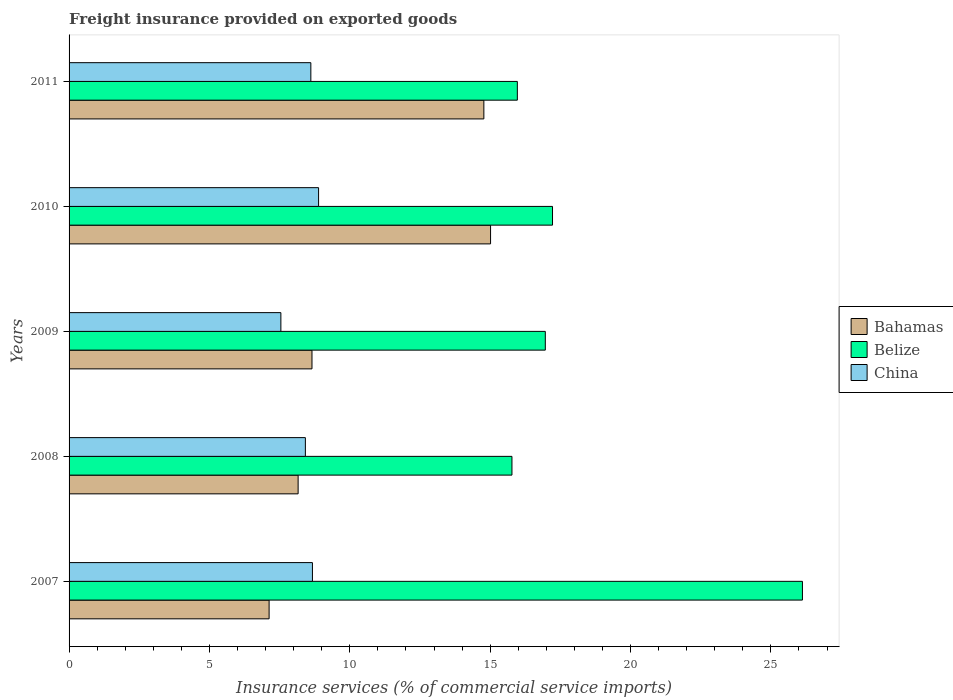How many groups of bars are there?
Provide a succinct answer. 5. Are the number of bars per tick equal to the number of legend labels?
Give a very brief answer. Yes. Are the number of bars on each tick of the Y-axis equal?
Ensure brevity in your answer.  Yes. How many bars are there on the 3rd tick from the top?
Your response must be concise. 3. In how many cases, is the number of bars for a given year not equal to the number of legend labels?
Provide a short and direct response. 0. What is the freight insurance provided on exported goods in Belize in 2011?
Offer a terse response. 15.97. Across all years, what is the maximum freight insurance provided on exported goods in Bahamas?
Provide a short and direct response. 15.01. Across all years, what is the minimum freight insurance provided on exported goods in Bahamas?
Your answer should be compact. 7.13. What is the total freight insurance provided on exported goods in Bahamas in the graph?
Offer a terse response. 53.73. What is the difference between the freight insurance provided on exported goods in Bahamas in 2007 and that in 2010?
Make the answer very short. -7.89. What is the difference between the freight insurance provided on exported goods in Bahamas in 2010 and the freight insurance provided on exported goods in China in 2008?
Provide a short and direct response. 6.6. What is the average freight insurance provided on exported goods in Belize per year?
Make the answer very short. 18.41. In the year 2007, what is the difference between the freight insurance provided on exported goods in Belize and freight insurance provided on exported goods in Bahamas?
Your answer should be compact. 19. What is the ratio of the freight insurance provided on exported goods in China in 2009 to that in 2010?
Your response must be concise. 0.85. What is the difference between the highest and the second highest freight insurance provided on exported goods in Belize?
Your response must be concise. 8.9. What is the difference between the highest and the lowest freight insurance provided on exported goods in China?
Give a very brief answer. 1.34. In how many years, is the freight insurance provided on exported goods in Belize greater than the average freight insurance provided on exported goods in Belize taken over all years?
Provide a short and direct response. 1. Is the sum of the freight insurance provided on exported goods in China in 2007 and 2011 greater than the maximum freight insurance provided on exported goods in Belize across all years?
Keep it short and to the point. No. What does the 1st bar from the top in 2011 represents?
Make the answer very short. China. What does the 3rd bar from the bottom in 2009 represents?
Offer a very short reply. China. Is it the case that in every year, the sum of the freight insurance provided on exported goods in Bahamas and freight insurance provided on exported goods in Belize is greater than the freight insurance provided on exported goods in China?
Keep it short and to the point. Yes. How many bars are there?
Ensure brevity in your answer.  15. How many years are there in the graph?
Keep it short and to the point. 5. Are the values on the major ticks of X-axis written in scientific E-notation?
Provide a succinct answer. No. Where does the legend appear in the graph?
Provide a short and direct response. Center right. How are the legend labels stacked?
Provide a succinct answer. Vertical. What is the title of the graph?
Provide a short and direct response. Freight insurance provided on exported goods. Does "Brazil" appear as one of the legend labels in the graph?
Your answer should be very brief. No. What is the label or title of the X-axis?
Offer a very short reply. Insurance services (% of commercial service imports). What is the Insurance services (% of commercial service imports) in Bahamas in 2007?
Provide a succinct answer. 7.13. What is the Insurance services (% of commercial service imports) of Belize in 2007?
Offer a very short reply. 26.13. What is the Insurance services (% of commercial service imports) of China in 2007?
Your answer should be compact. 8.67. What is the Insurance services (% of commercial service imports) of Bahamas in 2008?
Your response must be concise. 8.16. What is the Insurance services (% of commercial service imports) of Belize in 2008?
Your answer should be very brief. 15.78. What is the Insurance services (% of commercial service imports) in China in 2008?
Provide a short and direct response. 8.42. What is the Insurance services (% of commercial service imports) of Bahamas in 2009?
Make the answer very short. 8.65. What is the Insurance services (% of commercial service imports) of Belize in 2009?
Provide a short and direct response. 16.97. What is the Insurance services (% of commercial service imports) of China in 2009?
Offer a terse response. 7.55. What is the Insurance services (% of commercial service imports) of Bahamas in 2010?
Offer a very short reply. 15.01. What is the Insurance services (% of commercial service imports) of Belize in 2010?
Your answer should be compact. 17.22. What is the Insurance services (% of commercial service imports) in China in 2010?
Provide a short and direct response. 8.89. What is the Insurance services (% of commercial service imports) of Bahamas in 2011?
Ensure brevity in your answer.  14.78. What is the Insurance services (% of commercial service imports) of Belize in 2011?
Offer a very short reply. 15.97. What is the Insurance services (% of commercial service imports) of China in 2011?
Your answer should be very brief. 8.61. Across all years, what is the maximum Insurance services (% of commercial service imports) of Bahamas?
Keep it short and to the point. 15.01. Across all years, what is the maximum Insurance services (% of commercial service imports) of Belize?
Provide a succinct answer. 26.13. Across all years, what is the maximum Insurance services (% of commercial service imports) in China?
Ensure brevity in your answer.  8.89. Across all years, what is the minimum Insurance services (% of commercial service imports) of Bahamas?
Your answer should be very brief. 7.13. Across all years, what is the minimum Insurance services (% of commercial service imports) of Belize?
Give a very brief answer. 15.78. Across all years, what is the minimum Insurance services (% of commercial service imports) in China?
Give a very brief answer. 7.55. What is the total Insurance services (% of commercial service imports) of Bahamas in the graph?
Your answer should be very brief. 53.73. What is the total Insurance services (% of commercial service imports) in Belize in the graph?
Keep it short and to the point. 92.06. What is the total Insurance services (% of commercial service imports) in China in the graph?
Offer a very short reply. 42.13. What is the difference between the Insurance services (% of commercial service imports) in Bahamas in 2007 and that in 2008?
Your answer should be very brief. -1.03. What is the difference between the Insurance services (% of commercial service imports) in Belize in 2007 and that in 2008?
Offer a very short reply. 10.35. What is the difference between the Insurance services (% of commercial service imports) of China in 2007 and that in 2008?
Offer a terse response. 0.25. What is the difference between the Insurance services (% of commercial service imports) of Bahamas in 2007 and that in 2009?
Provide a succinct answer. -1.53. What is the difference between the Insurance services (% of commercial service imports) of Belize in 2007 and that in 2009?
Ensure brevity in your answer.  9.16. What is the difference between the Insurance services (% of commercial service imports) of China in 2007 and that in 2009?
Offer a very short reply. 1.12. What is the difference between the Insurance services (% of commercial service imports) of Bahamas in 2007 and that in 2010?
Give a very brief answer. -7.89. What is the difference between the Insurance services (% of commercial service imports) of Belize in 2007 and that in 2010?
Provide a succinct answer. 8.9. What is the difference between the Insurance services (% of commercial service imports) of China in 2007 and that in 2010?
Offer a very short reply. -0.22. What is the difference between the Insurance services (% of commercial service imports) of Bahamas in 2007 and that in 2011?
Keep it short and to the point. -7.65. What is the difference between the Insurance services (% of commercial service imports) in Belize in 2007 and that in 2011?
Ensure brevity in your answer.  10.16. What is the difference between the Insurance services (% of commercial service imports) of China in 2007 and that in 2011?
Provide a succinct answer. 0.06. What is the difference between the Insurance services (% of commercial service imports) in Bahamas in 2008 and that in 2009?
Make the answer very short. -0.49. What is the difference between the Insurance services (% of commercial service imports) of Belize in 2008 and that in 2009?
Offer a very short reply. -1.19. What is the difference between the Insurance services (% of commercial service imports) of China in 2008 and that in 2009?
Provide a succinct answer. 0.87. What is the difference between the Insurance services (% of commercial service imports) in Bahamas in 2008 and that in 2010?
Offer a very short reply. -6.86. What is the difference between the Insurance services (% of commercial service imports) of Belize in 2008 and that in 2010?
Offer a very short reply. -1.45. What is the difference between the Insurance services (% of commercial service imports) in China in 2008 and that in 2010?
Offer a very short reply. -0.47. What is the difference between the Insurance services (% of commercial service imports) of Bahamas in 2008 and that in 2011?
Your response must be concise. -6.62. What is the difference between the Insurance services (% of commercial service imports) in Belize in 2008 and that in 2011?
Your answer should be very brief. -0.19. What is the difference between the Insurance services (% of commercial service imports) in China in 2008 and that in 2011?
Keep it short and to the point. -0.19. What is the difference between the Insurance services (% of commercial service imports) in Bahamas in 2009 and that in 2010?
Ensure brevity in your answer.  -6.36. What is the difference between the Insurance services (% of commercial service imports) in Belize in 2009 and that in 2010?
Your response must be concise. -0.26. What is the difference between the Insurance services (% of commercial service imports) of China in 2009 and that in 2010?
Your response must be concise. -1.34. What is the difference between the Insurance services (% of commercial service imports) in Bahamas in 2009 and that in 2011?
Keep it short and to the point. -6.12. What is the difference between the Insurance services (% of commercial service imports) of Belize in 2009 and that in 2011?
Make the answer very short. 1. What is the difference between the Insurance services (% of commercial service imports) of China in 2009 and that in 2011?
Give a very brief answer. -1.07. What is the difference between the Insurance services (% of commercial service imports) of Bahamas in 2010 and that in 2011?
Offer a very short reply. 0.24. What is the difference between the Insurance services (% of commercial service imports) of Belize in 2010 and that in 2011?
Offer a very short reply. 1.25. What is the difference between the Insurance services (% of commercial service imports) in China in 2010 and that in 2011?
Ensure brevity in your answer.  0.28. What is the difference between the Insurance services (% of commercial service imports) in Bahamas in 2007 and the Insurance services (% of commercial service imports) in Belize in 2008?
Give a very brief answer. -8.65. What is the difference between the Insurance services (% of commercial service imports) of Bahamas in 2007 and the Insurance services (% of commercial service imports) of China in 2008?
Ensure brevity in your answer.  -1.29. What is the difference between the Insurance services (% of commercial service imports) in Belize in 2007 and the Insurance services (% of commercial service imports) in China in 2008?
Make the answer very short. 17.71. What is the difference between the Insurance services (% of commercial service imports) in Bahamas in 2007 and the Insurance services (% of commercial service imports) in Belize in 2009?
Provide a short and direct response. -9.84. What is the difference between the Insurance services (% of commercial service imports) of Bahamas in 2007 and the Insurance services (% of commercial service imports) of China in 2009?
Offer a very short reply. -0.42. What is the difference between the Insurance services (% of commercial service imports) of Belize in 2007 and the Insurance services (% of commercial service imports) of China in 2009?
Offer a very short reply. 18.58. What is the difference between the Insurance services (% of commercial service imports) in Bahamas in 2007 and the Insurance services (% of commercial service imports) in Belize in 2010?
Give a very brief answer. -10.1. What is the difference between the Insurance services (% of commercial service imports) of Bahamas in 2007 and the Insurance services (% of commercial service imports) of China in 2010?
Your answer should be compact. -1.76. What is the difference between the Insurance services (% of commercial service imports) of Belize in 2007 and the Insurance services (% of commercial service imports) of China in 2010?
Make the answer very short. 17.24. What is the difference between the Insurance services (% of commercial service imports) in Bahamas in 2007 and the Insurance services (% of commercial service imports) in Belize in 2011?
Offer a very short reply. -8.84. What is the difference between the Insurance services (% of commercial service imports) of Bahamas in 2007 and the Insurance services (% of commercial service imports) of China in 2011?
Offer a terse response. -1.49. What is the difference between the Insurance services (% of commercial service imports) of Belize in 2007 and the Insurance services (% of commercial service imports) of China in 2011?
Your answer should be very brief. 17.51. What is the difference between the Insurance services (% of commercial service imports) of Bahamas in 2008 and the Insurance services (% of commercial service imports) of Belize in 2009?
Provide a short and direct response. -8.81. What is the difference between the Insurance services (% of commercial service imports) in Bahamas in 2008 and the Insurance services (% of commercial service imports) in China in 2009?
Keep it short and to the point. 0.61. What is the difference between the Insurance services (% of commercial service imports) in Belize in 2008 and the Insurance services (% of commercial service imports) in China in 2009?
Offer a terse response. 8.23. What is the difference between the Insurance services (% of commercial service imports) of Bahamas in 2008 and the Insurance services (% of commercial service imports) of Belize in 2010?
Offer a terse response. -9.06. What is the difference between the Insurance services (% of commercial service imports) of Bahamas in 2008 and the Insurance services (% of commercial service imports) of China in 2010?
Ensure brevity in your answer.  -0.73. What is the difference between the Insurance services (% of commercial service imports) in Belize in 2008 and the Insurance services (% of commercial service imports) in China in 2010?
Keep it short and to the point. 6.89. What is the difference between the Insurance services (% of commercial service imports) of Bahamas in 2008 and the Insurance services (% of commercial service imports) of Belize in 2011?
Your answer should be compact. -7.81. What is the difference between the Insurance services (% of commercial service imports) of Bahamas in 2008 and the Insurance services (% of commercial service imports) of China in 2011?
Your response must be concise. -0.45. What is the difference between the Insurance services (% of commercial service imports) in Belize in 2008 and the Insurance services (% of commercial service imports) in China in 2011?
Give a very brief answer. 7.16. What is the difference between the Insurance services (% of commercial service imports) of Bahamas in 2009 and the Insurance services (% of commercial service imports) of Belize in 2010?
Your answer should be very brief. -8.57. What is the difference between the Insurance services (% of commercial service imports) in Bahamas in 2009 and the Insurance services (% of commercial service imports) in China in 2010?
Keep it short and to the point. -0.23. What is the difference between the Insurance services (% of commercial service imports) of Belize in 2009 and the Insurance services (% of commercial service imports) of China in 2010?
Provide a short and direct response. 8.08. What is the difference between the Insurance services (% of commercial service imports) in Bahamas in 2009 and the Insurance services (% of commercial service imports) in Belize in 2011?
Your answer should be very brief. -7.32. What is the difference between the Insurance services (% of commercial service imports) of Bahamas in 2009 and the Insurance services (% of commercial service imports) of China in 2011?
Offer a very short reply. 0.04. What is the difference between the Insurance services (% of commercial service imports) of Belize in 2009 and the Insurance services (% of commercial service imports) of China in 2011?
Offer a very short reply. 8.35. What is the difference between the Insurance services (% of commercial service imports) in Bahamas in 2010 and the Insurance services (% of commercial service imports) in Belize in 2011?
Your response must be concise. -0.95. What is the difference between the Insurance services (% of commercial service imports) in Bahamas in 2010 and the Insurance services (% of commercial service imports) in China in 2011?
Provide a short and direct response. 6.4. What is the difference between the Insurance services (% of commercial service imports) in Belize in 2010 and the Insurance services (% of commercial service imports) in China in 2011?
Your answer should be very brief. 8.61. What is the average Insurance services (% of commercial service imports) in Bahamas per year?
Your answer should be compact. 10.75. What is the average Insurance services (% of commercial service imports) in Belize per year?
Offer a very short reply. 18.41. What is the average Insurance services (% of commercial service imports) of China per year?
Your answer should be compact. 8.43. In the year 2007, what is the difference between the Insurance services (% of commercial service imports) in Bahamas and Insurance services (% of commercial service imports) in Belize?
Offer a terse response. -19. In the year 2007, what is the difference between the Insurance services (% of commercial service imports) in Bahamas and Insurance services (% of commercial service imports) in China?
Provide a short and direct response. -1.54. In the year 2007, what is the difference between the Insurance services (% of commercial service imports) of Belize and Insurance services (% of commercial service imports) of China?
Offer a very short reply. 17.46. In the year 2008, what is the difference between the Insurance services (% of commercial service imports) in Bahamas and Insurance services (% of commercial service imports) in Belize?
Provide a succinct answer. -7.62. In the year 2008, what is the difference between the Insurance services (% of commercial service imports) in Bahamas and Insurance services (% of commercial service imports) in China?
Provide a succinct answer. -0.26. In the year 2008, what is the difference between the Insurance services (% of commercial service imports) of Belize and Insurance services (% of commercial service imports) of China?
Provide a succinct answer. 7.36. In the year 2009, what is the difference between the Insurance services (% of commercial service imports) of Bahamas and Insurance services (% of commercial service imports) of Belize?
Offer a very short reply. -8.31. In the year 2009, what is the difference between the Insurance services (% of commercial service imports) in Bahamas and Insurance services (% of commercial service imports) in China?
Ensure brevity in your answer.  1.11. In the year 2009, what is the difference between the Insurance services (% of commercial service imports) of Belize and Insurance services (% of commercial service imports) of China?
Keep it short and to the point. 9.42. In the year 2010, what is the difference between the Insurance services (% of commercial service imports) in Bahamas and Insurance services (% of commercial service imports) in Belize?
Your response must be concise. -2.21. In the year 2010, what is the difference between the Insurance services (% of commercial service imports) of Bahamas and Insurance services (% of commercial service imports) of China?
Give a very brief answer. 6.13. In the year 2010, what is the difference between the Insurance services (% of commercial service imports) in Belize and Insurance services (% of commercial service imports) in China?
Give a very brief answer. 8.33. In the year 2011, what is the difference between the Insurance services (% of commercial service imports) in Bahamas and Insurance services (% of commercial service imports) in Belize?
Your answer should be very brief. -1.19. In the year 2011, what is the difference between the Insurance services (% of commercial service imports) of Bahamas and Insurance services (% of commercial service imports) of China?
Your answer should be compact. 6.16. In the year 2011, what is the difference between the Insurance services (% of commercial service imports) of Belize and Insurance services (% of commercial service imports) of China?
Ensure brevity in your answer.  7.36. What is the ratio of the Insurance services (% of commercial service imports) of Bahamas in 2007 to that in 2008?
Provide a succinct answer. 0.87. What is the ratio of the Insurance services (% of commercial service imports) in Belize in 2007 to that in 2008?
Provide a short and direct response. 1.66. What is the ratio of the Insurance services (% of commercial service imports) in China in 2007 to that in 2008?
Your answer should be very brief. 1.03. What is the ratio of the Insurance services (% of commercial service imports) of Bahamas in 2007 to that in 2009?
Your answer should be very brief. 0.82. What is the ratio of the Insurance services (% of commercial service imports) of Belize in 2007 to that in 2009?
Give a very brief answer. 1.54. What is the ratio of the Insurance services (% of commercial service imports) of China in 2007 to that in 2009?
Give a very brief answer. 1.15. What is the ratio of the Insurance services (% of commercial service imports) in Bahamas in 2007 to that in 2010?
Your answer should be compact. 0.47. What is the ratio of the Insurance services (% of commercial service imports) in Belize in 2007 to that in 2010?
Your answer should be very brief. 1.52. What is the ratio of the Insurance services (% of commercial service imports) of China in 2007 to that in 2010?
Make the answer very short. 0.98. What is the ratio of the Insurance services (% of commercial service imports) of Bahamas in 2007 to that in 2011?
Your response must be concise. 0.48. What is the ratio of the Insurance services (% of commercial service imports) in Belize in 2007 to that in 2011?
Keep it short and to the point. 1.64. What is the ratio of the Insurance services (% of commercial service imports) in China in 2007 to that in 2011?
Your answer should be compact. 1.01. What is the ratio of the Insurance services (% of commercial service imports) of Bahamas in 2008 to that in 2009?
Your response must be concise. 0.94. What is the ratio of the Insurance services (% of commercial service imports) in Belize in 2008 to that in 2009?
Offer a very short reply. 0.93. What is the ratio of the Insurance services (% of commercial service imports) in China in 2008 to that in 2009?
Keep it short and to the point. 1.12. What is the ratio of the Insurance services (% of commercial service imports) of Bahamas in 2008 to that in 2010?
Your answer should be very brief. 0.54. What is the ratio of the Insurance services (% of commercial service imports) of Belize in 2008 to that in 2010?
Your answer should be compact. 0.92. What is the ratio of the Insurance services (% of commercial service imports) in China in 2008 to that in 2010?
Make the answer very short. 0.95. What is the ratio of the Insurance services (% of commercial service imports) in Bahamas in 2008 to that in 2011?
Give a very brief answer. 0.55. What is the ratio of the Insurance services (% of commercial service imports) of China in 2008 to that in 2011?
Your answer should be very brief. 0.98. What is the ratio of the Insurance services (% of commercial service imports) of Bahamas in 2009 to that in 2010?
Ensure brevity in your answer.  0.58. What is the ratio of the Insurance services (% of commercial service imports) in Belize in 2009 to that in 2010?
Your answer should be very brief. 0.99. What is the ratio of the Insurance services (% of commercial service imports) in China in 2009 to that in 2010?
Ensure brevity in your answer.  0.85. What is the ratio of the Insurance services (% of commercial service imports) of Bahamas in 2009 to that in 2011?
Offer a terse response. 0.59. What is the ratio of the Insurance services (% of commercial service imports) of Belize in 2009 to that in 2011?
Give a very brief answer. 1.06. What is the ratio of the Insurance services (% of commercial service imports) in China in 2009 to that in 2011?
Provide a succinct answer. 0.88. What is the ratio of the Insurance services (% of commercial service imports) in Bahamas in 2010 to that in 2011?
Give a very brief answer. 1.02. What is the ratio of the Insurance services (% of commercial service imports) in Belize in 2010 to that in 2011?
Ensure brevity in your answer.  1.08. What is the ratio of the Insurance services (% of commercial service imports) in China in 2010 to that in 2011?
Give a very brief answer. 1.03. What is the difference between the highest and the second highest Insurance services (% of commercial service imports) of Bahamas?
Give a very brief answer. 0.24. What is the difference between the highest and the second highest Insurance services (% of commercial service imports) of Belize?
Offer a terse response. 8.9. What is the difference between the highest and the second highest Insurance services (% of commercial service imports) in China?
Provide a short and direct response. 0.22. What is the difference between the highest and the lowest Insurance services (% of commercial service imports) of Bahamas?
Offer a terse response. 7.89. What is the difference between the highest and the lowest Insurance services (% of commercial service imports) in Belize?
Your answer should be compact. 10.35. What is the difference between the highest and the lowest Insurance services (% of commercial service imports) of China?
Your response must be concise. 1.34. 